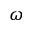Convert formula to latex. <formula><loc_0><loc_0><loc_500><loc_500>\omega</formula> 